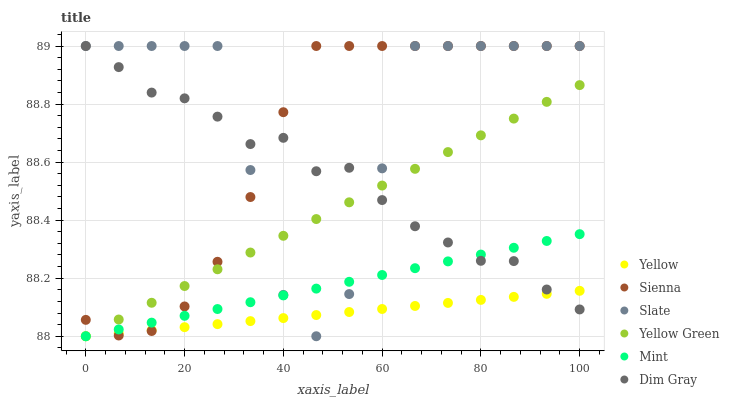Does Yellow have the minimum area under the curve?
Answer yes or no. Yes. Does Slate have the maximum area under the curve?
Answer yes or no. Yes. Does Yellow Green have the minimum area under the curve?
Answer yes or no. No. Does Yellow Green have the maximum area under the curve?
Answer yes or no. No. Is Mint the smoothest?
Answer yes or no. Yes. Is Slate the roughest?
Answer yes or no. Yes. Is Yellow Green the smoothest?
Answer yes or no. No. Is Yellow Green the roughest?
Answer yes or no. No. Does Yellow Green have the lowest value?
Answer yes or no. Yes. Does Slate have the lowest value?
Answer yes or no. No. Does Sienna have the highest value?
Answer yes or no. Yes. Does Yellow Green have the highest value?
Answer yes or no. No. Does Slate intersect Dim Gray?
Answer yes or no. Yes. Is Slate less than Dim Gray?
Answer yes or no. No. Is Slate greater than Dim Gray?
Answer yes or no. No. 